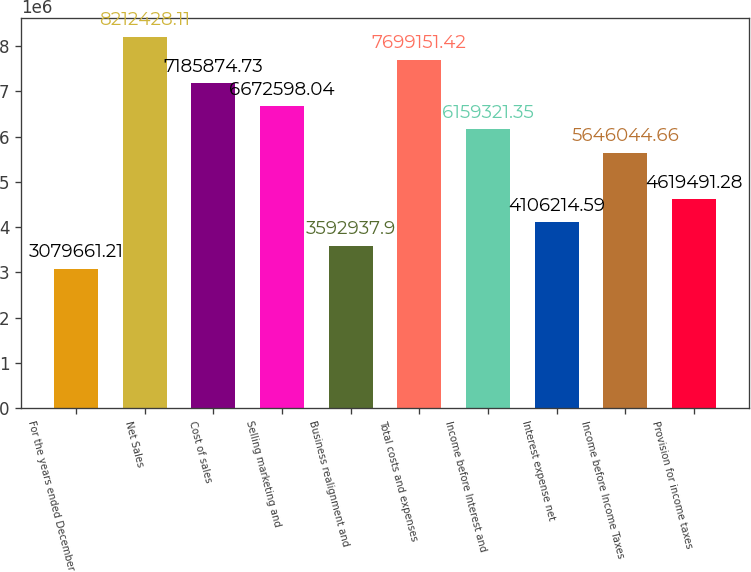Convert chart. <chart><loc_0><loc_0><loc_500><loc_500><bar_chart><fcel>For the years ended December<fcel>Net Sales<fcel>Cost of sales<fcel>Selling marketing and<fcel>Business realignment and<fcel>Total costs and expenses<fcel>Income before Interest and<fcel>Interest expense net<fcel>Income before Income Taxes<fcel>Provision for income taxes<nl><fcel>3.07966e+06<fcel>8.21243e+06<fcel>7.18587e+06<fcel>6.6726e+06<fcel>3.59294e+06<fcel>7.69915e+06<fcel>6.15932e+06<fcel>4.10621e+06<fcel>5.64604e+06<fcel>4.61949e+06<nl></chart> 